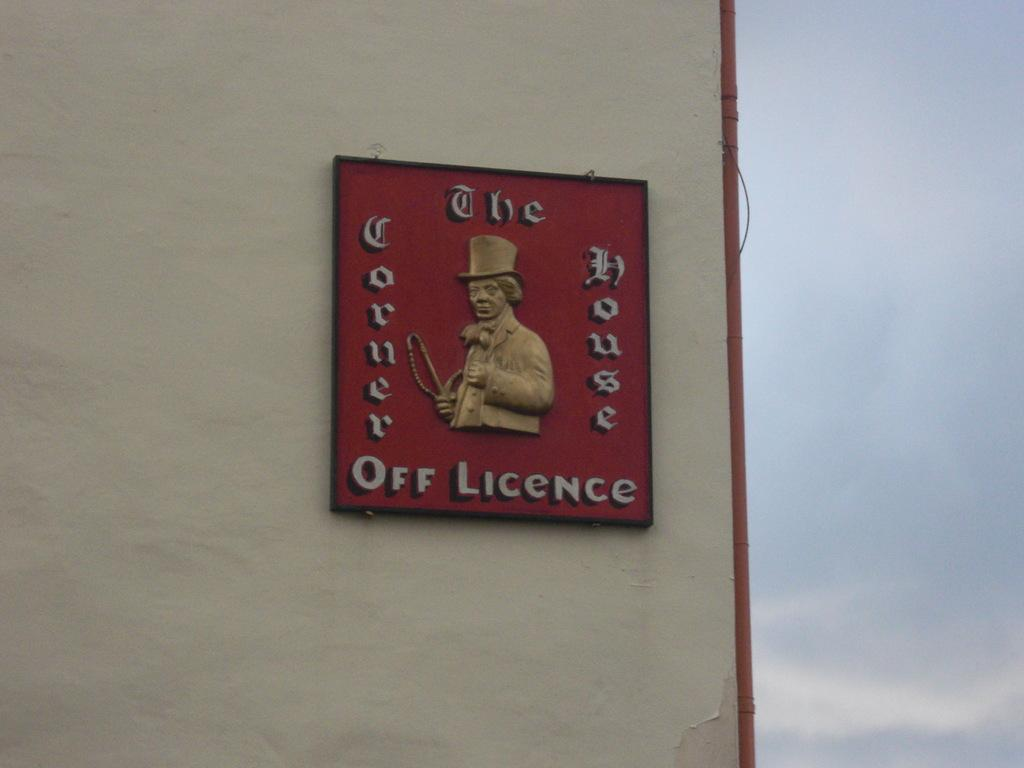<image>
Relay a brief, clear account of the picture shown. a plaque on a wall that says 'the corner house off licence' on it 